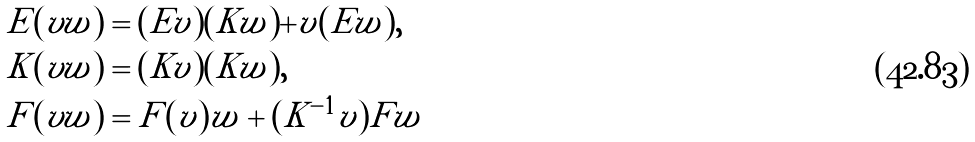<formula> <loc_0><loc_0><loc_500><loc_500>E ( v w ) & = ( E v ) ( K w ) + v ( E w ) , \\ K ( v w ) & = ( K v ) ( K w ) , \\ F ( v w ) & = F ( v ) w + ( K ^ { - 1 } v ) F w</formula> 